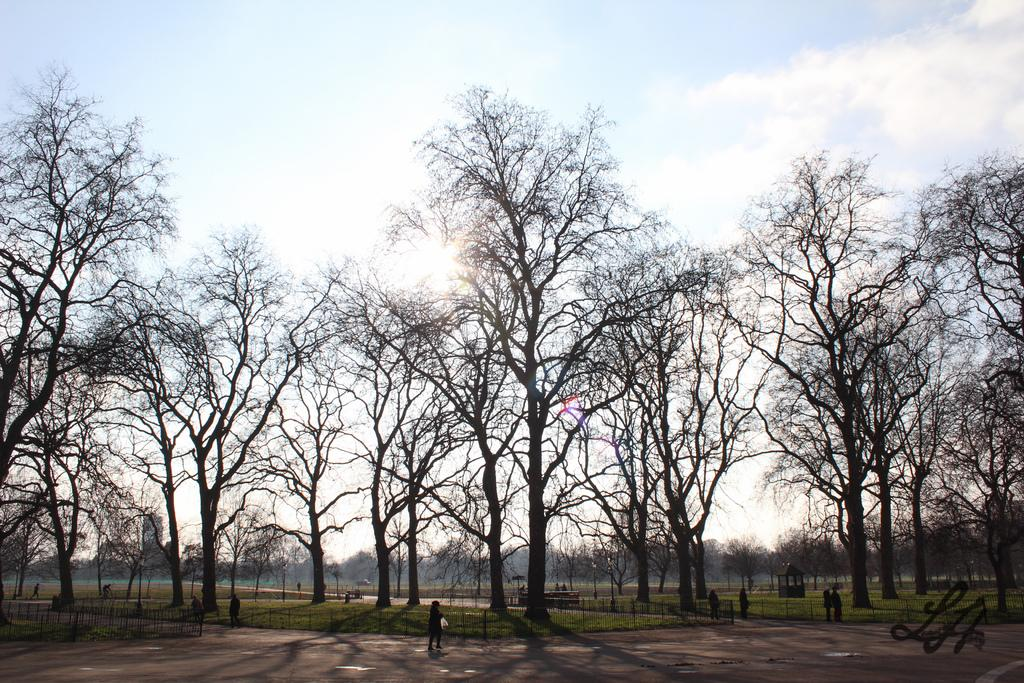How many people are in the image? There is a group of people in the image. What type of natural elements can be seen in the image? There are trees in the image. What type of barrier is present in the image? There is a fence in the image. Can you describe any additional features of the image? There is a watermark at the right bottom of the image. Where is the baby playing in the image? There is no baby present in the image. What type of day is depicted in the image? The image does not depict a specific day; it only shows a group of people, trees, a fence, and a watermark. 